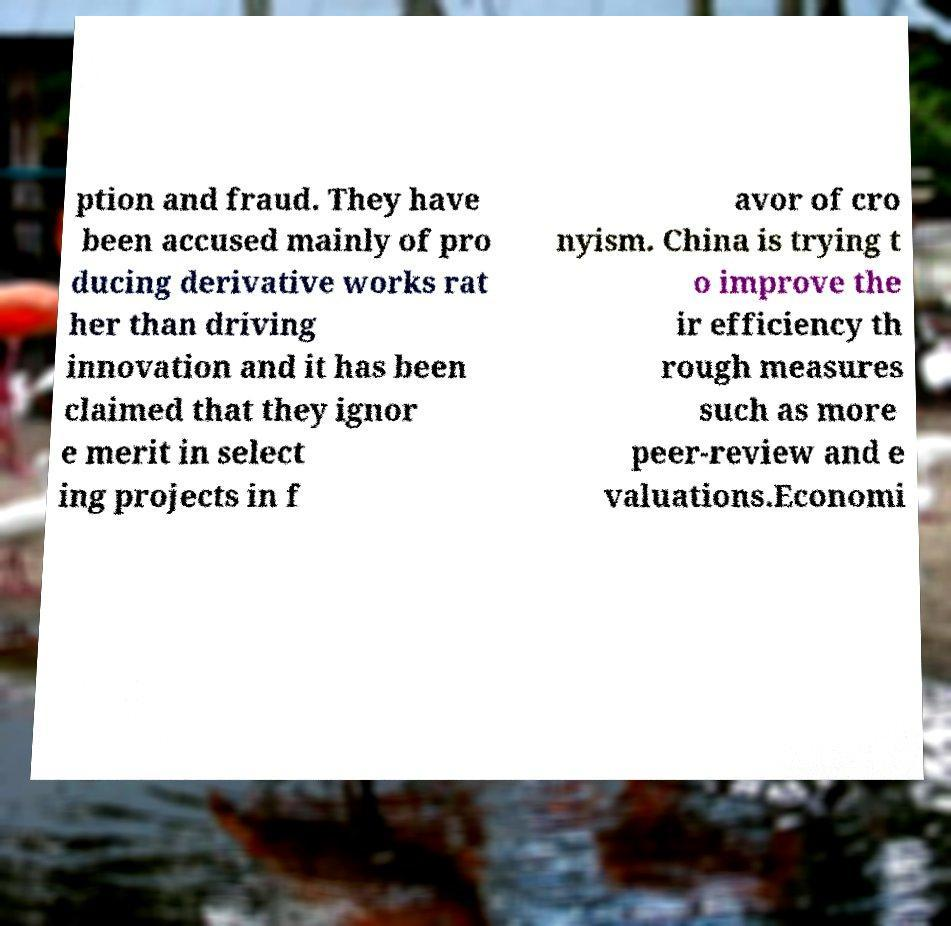What messages or text are displayed in this image? I need them in a readable, typed format. ption and fraud. They have been accused mainly of pro ducing derivative works rat her than driving innovation and it has been claimed that they ignor e merit in select ing projects in f avor of cro nyism. China is trying t o improve the ir efficiency th rough measures such as more peer-review and e valuations.Economi 